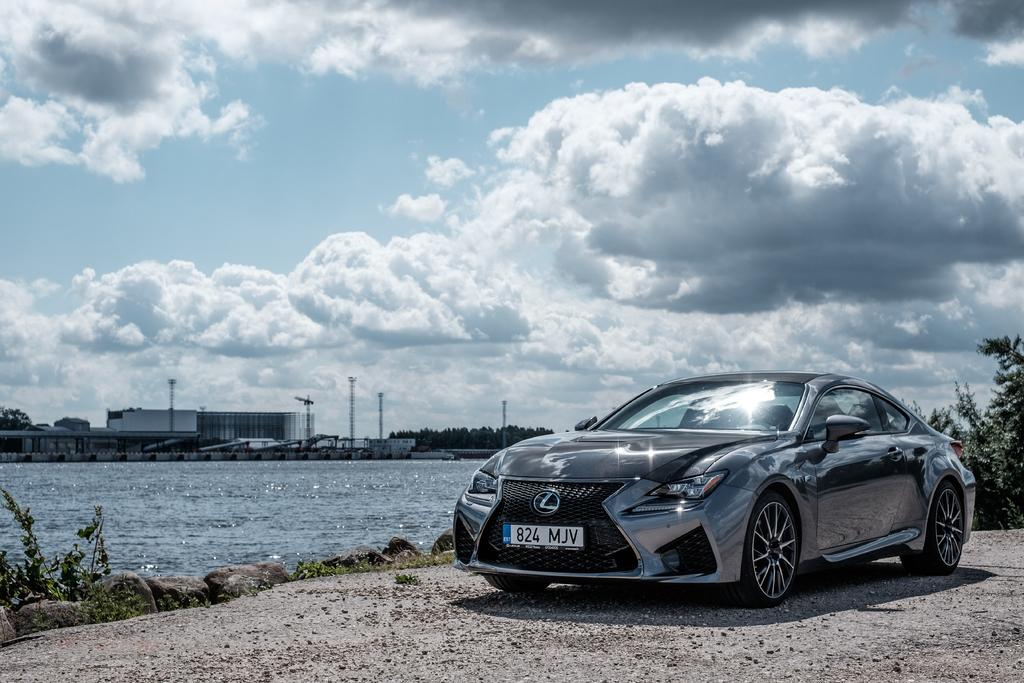What can be seen on the right side of the image? There is a car on the right side of the image. What is located at the bottom of the image? There are stones, plants, land, and water at the bottom of the image. What is happening in the water at the bottom of the image? Waves are visible in the water. What can be seen in the background of the image? There are trees, a building, poles, and the sky in the background of the image. What is present in the sky? Clouds are present in the sky. What design can be seen on the car's hood in the image? There is no specific design mentioned on the car's hood in the provided facts, so it cannot be determined from the image. How many details can be seen on the stones at the bottom of the image? The provided facts do not mention any specific details on the stones, so it cannot be determined from the image. 